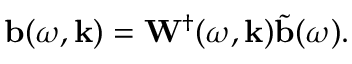Convert formula to latex. <formula><loc_0><loc_0><loc_500><loc_500>b ( \omega , k ) = W ^ { \dagger } ( \omega , k ) \tilde { b } ( \omega ) .</formula> 